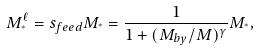<formula> <loc_0><loc_0><loc_500><loc_500>M _ { ^ { * } } ^ { \ell } = s _ { f e e d } M _ { ^ { * } } = \frac { 1 } { 1 + ( M _ { b y } / M ) ^ { \gamma } } M _ { ^ { * } } ,</formula> 